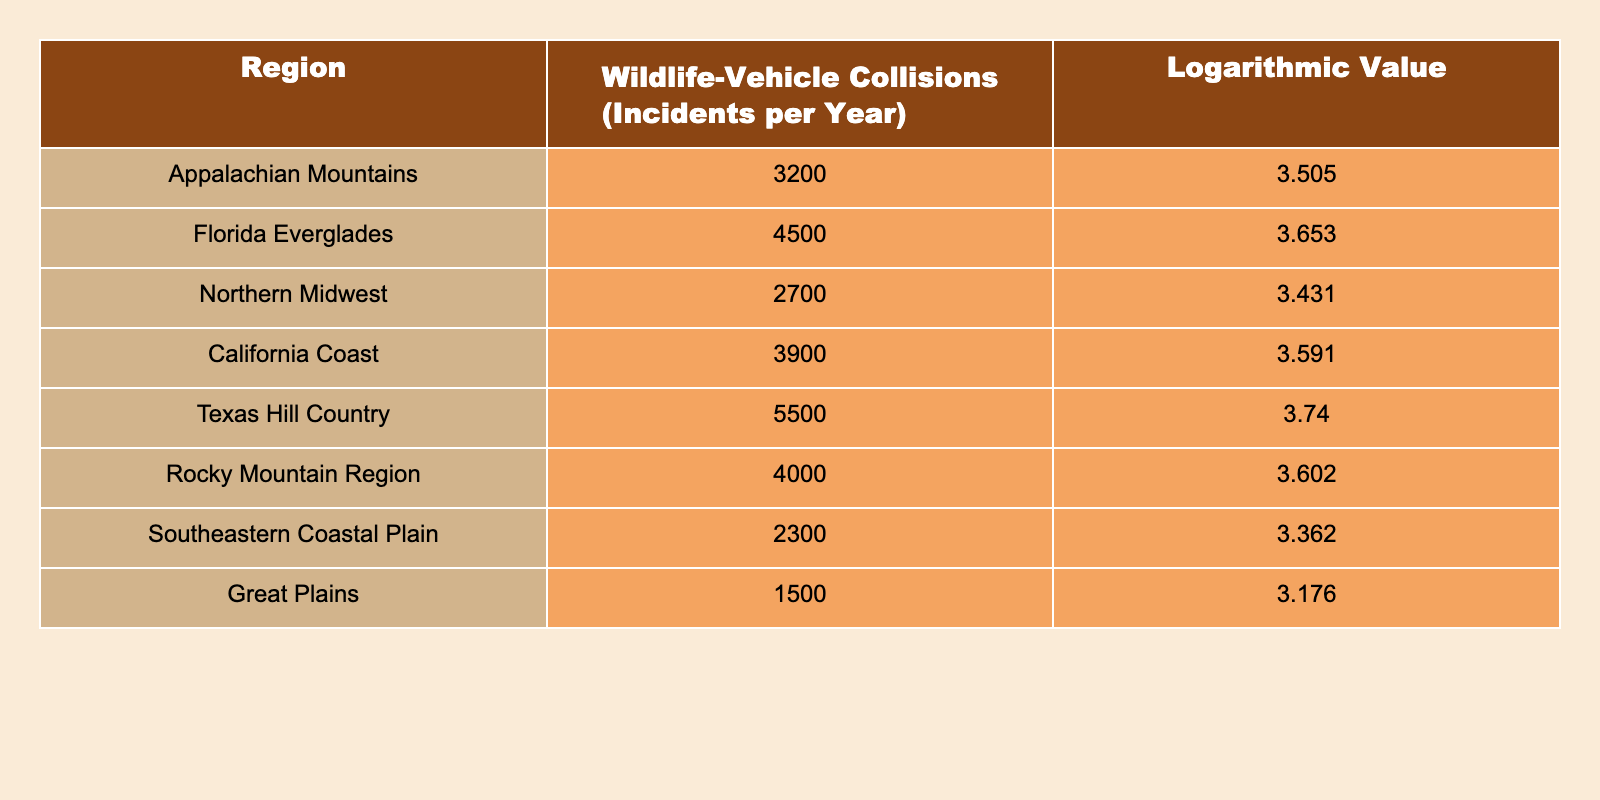What is the region with the highest number of wildlife-vehicle collisions? According to the table, the Texas Hill Country has the highest number of wildlife-vehicle collisions, with 5500 incidents per year.
Answer: Texas Hill Country Which region has the lowest logarithmic value of wildlife-vehicle collisions? The Great Plains has the lowest logarithmic value at 3.176, indicating it also has the fewest wildlife-vehicle collisions in comparison to other regions.
Answer: Great Plains What is the total number of wildlife-vehicle collisions reported in the Appalachian Mountains and Northern Midwest combined? By adding the wildlife-vehicle collisions in the Appalachian Mountains (3200) and Northern Midwest (2700), the total is 3200 + 2700 = 5900 incidents.
Answer: 5900 Is it true that the wildlife-vehicle collisions in the Florida Everglades exceed those in the California Coast? A comparison of the incidents shows the Florida Everglades has 4500 collisions compared to the California Coast with 3900; therefore, it is true that the Florida Everglades has more collisions.
Answer: Yes What is the average number of wildlife-vehicle collisions across all the regions listed in the table? To find the average, sum all the incidents (3200 + 4500 + 2700 + 3900 + 5500 + 4000 + 2300 + 1500 = 28200) and divide by the number of regions (8), giving an average of 28200 / 8 = 3525
Answer: 3525 Among the regions listed, which has a logarithmic value closest to 3.5? The Northern Midwest has a logarithmic value of 3.431, and the Appalachian Mountains has a value of 3.505. Comparing these, the Appalachian Mountains is closer to 3.5.
Answer: Appalachian Mountains How many regions have more than 4000 wildlife-vehicle collisions? The Texas Hill Country (5500), Florida Everglades (4500), Rocky Mountain Region (4000), and California Coast (3900) are the regions; therefore, there are three regions with more than 4000 collisions.
Answer: 3 What is the difference in the number of wildlife-vehicle collisions between the Texas Hill Country and the Great Plains? The difference is calculated by subtracting the Great Plains incidents (1500) from the Texas Hill Country (5500), resulting in a difference of 5500 - 1500 = 4000.
Answer: 4000 